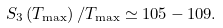Convert formula to latex. <formula><loc_0><loc_0><loc_500><loc_500>S _ { 3 } \left ( T _ { \max } \right ) / T _ { \max } \simeq 1 0 5 - 1 0 9 .</formula> 